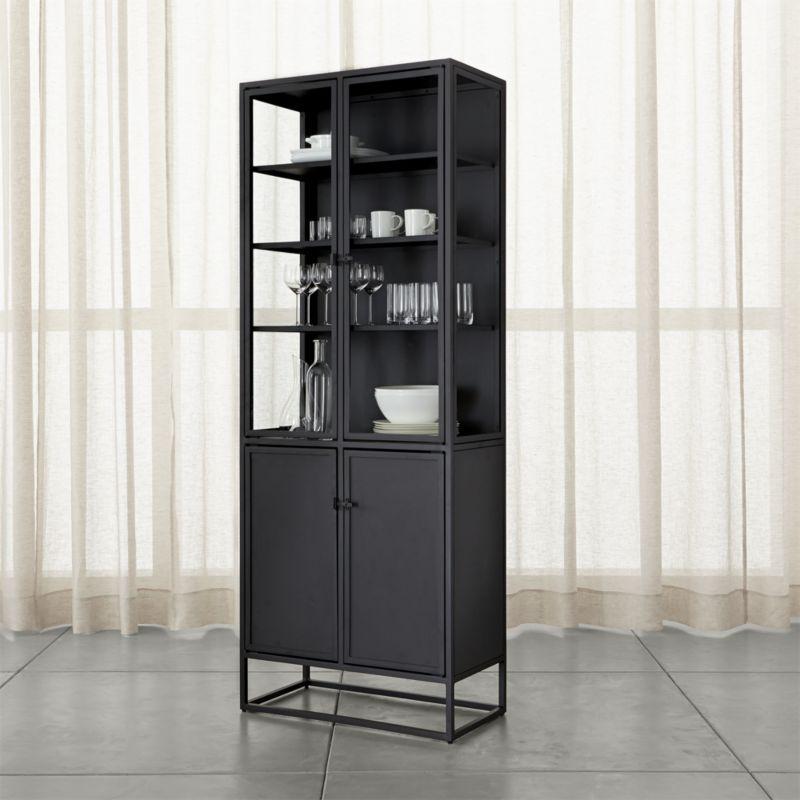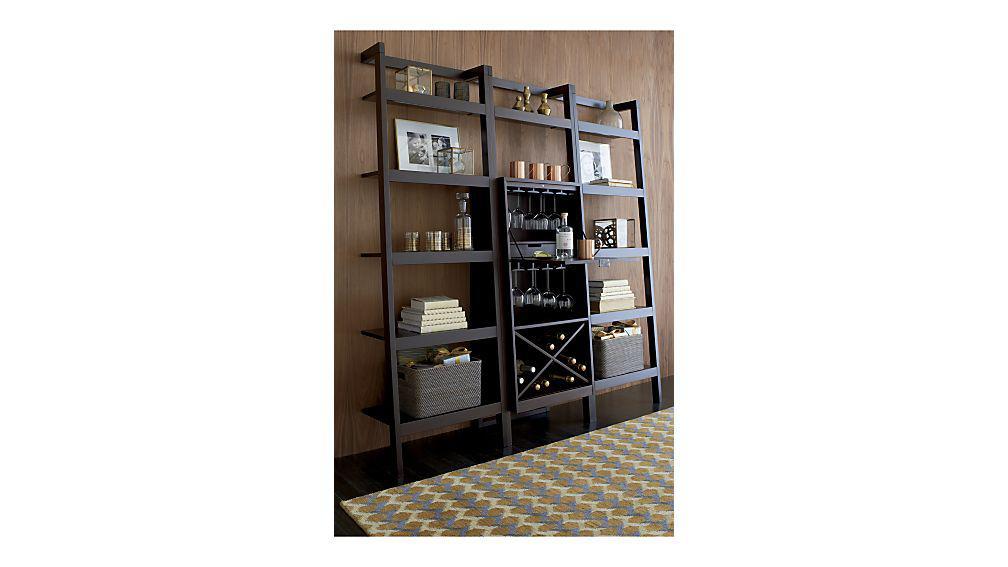The first image is the image on the left, the second image is the image on the right. Assess this claim about the two images: "The shelf in the image on the left is white, while the shelf on the right is darker.". Correct or not? Answer yes or no. No. The first image is the image on the left, the second image is the image on the right. Evaluate the accuracy of this statement regarding the images: "An image shows a dark storage unit with rows of shelves flanking an X-shaped compartment that holds wine bottles.". Is it true? Answer yes or no. Yes. 